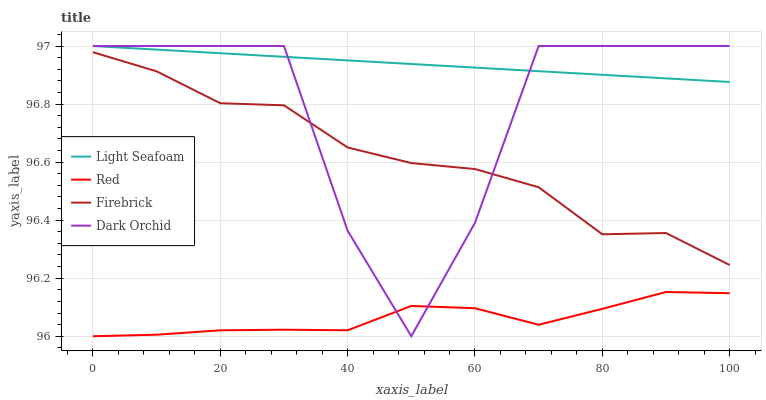Does Red have the minimum area under the curve?
Answer yes or no. Yes. Does Light Seafoam have the maximum area under the curve?
Answer yes or no. Yes. Does Dark Orchid have the minimum area under the curve?
Answer yes or no. No. Does Dark Orchid have the maximum area under the curve?
Answer yes or no. No. Is Light Seafoam the smoothest?
Answer yes or no. Yes. Is Dark Orchid the roughest?
Answer yes or no. Yes. Is Dark Orchid the smoothest?
Answer yes or no. No. Is Light Seafoam the roughest?
Answer yes or no. No. Does Red have the lowest value?
Answer yes or no. Yes. Does Dark Orchid have the lowest value?
Answer yes or no. No. Does Dark Orchid have the highest value?
Answer yes or no. Yes. Does Red have the highest value?
Answer yes or no. No. Is Red less than Light Seafoam?
Answer yes or no. Yes. Is Firebrick greater than Red?
Answer yes or no. Yes. Does Light Seafoam intersect Dark Orchid?
Answer yes or no. Yes. Is Light Seafoam less than Dark Orchid?
Answer yes or no. No. Is Light Seafoam greater than Dark Orchid?
Answer yes or no. No. Does Red intersect Light Seafoam?
Answer yes or no. No. 